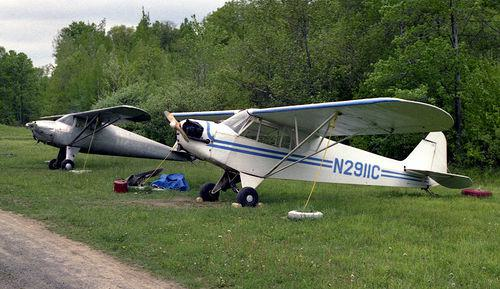Do the aeroplanes look like they are in working condition or are they abandoned? The aeroplanes look like they are in a well-used condition with no visible signs of recent flights. Items such as a tarp and a few miscellaneous objects underneath one of them may suggest maintenance activity rather than abandonment. 